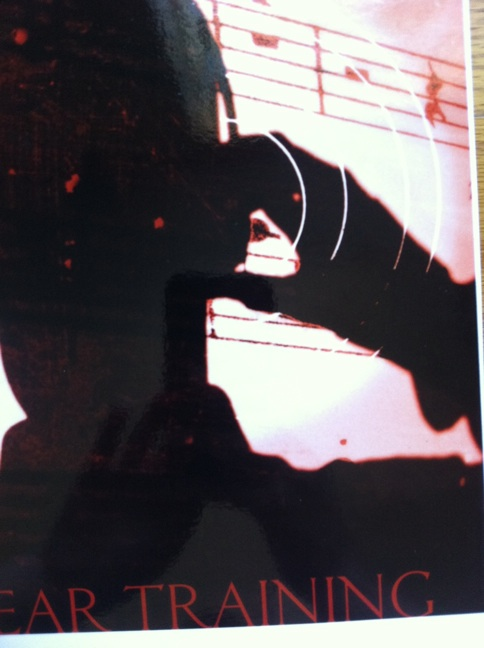Can you describe the mood conveyed by this image? The image conveys a mysterious and introspective mood. The dark shadows and the blurred lines give a sense of depth and contemplation, possibly related to the focused practice of ear training. 